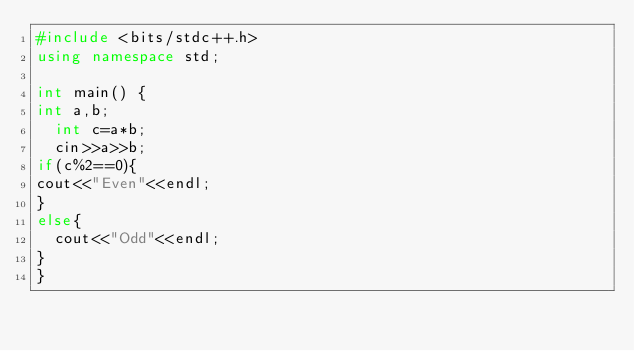Convert code to text. <code><loc_0><loc_0><loc_500><loc_500><_C++_>#include <bits/stdc++.h>
using namespace std;

int main() {
int a,b;
  int c=a*b;
  cin>>a>>b;
if(c%2==0){
cout<<"Even"<<endl;
}
else{
  cout<<"Odd"<<endl;
}
}
</code> 